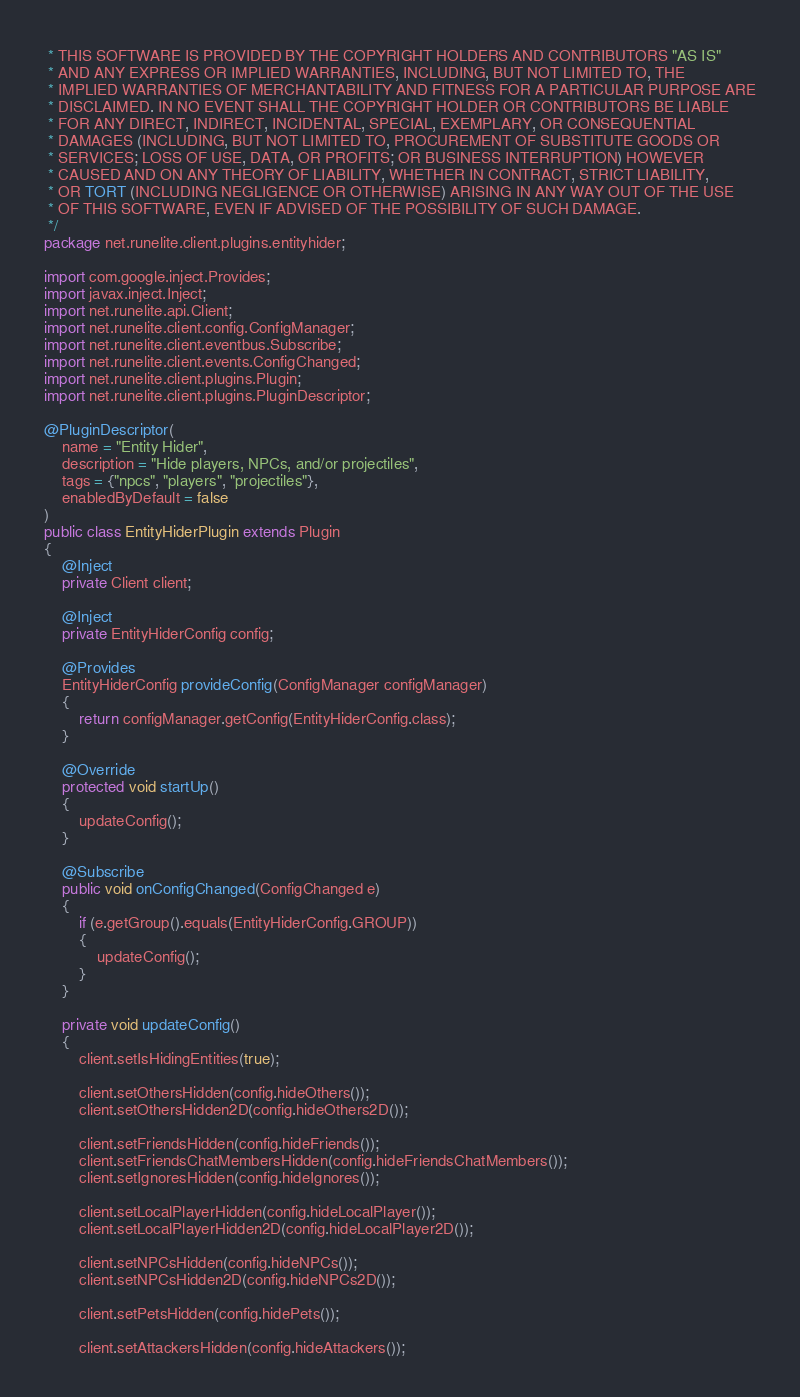<code> <loc_0><loc_0><loc_500><loc_500><_Java_> * THIS SOFTWARE IS PROVIDED BY THE COPYRIGHT HOLDERS AND CONTRIBUTORS "AS IS"
 * AND ANY EXPRESS OR IMPLIED WARRANTIES, INCLUDING, BUT NOT LIMITED TO, THE
 * IMPLIED WARRANTIES OF MERCHANTABILITY AND FITNESS FOR A PARTICULAR PURPOSE ARE
 * DISCLAIMED. IN NO EVENT SHALL THE COPYRIGHT HOLDER OR CONTRIBUTORS BE LIABLE
 * FOR ANY DIRECT, INDIRECT, INCIDENTAL, SPECIAL, EXEMPLARY, OR CONSEQUENTIAL
 * DAMAGES (INCLUDING, BUT NOT LIMITED TO, PROCUREMENT OF SUBSTITUTE GOODS OR
 * SERVICES; LOSS OF USE, DATA, OR PROFITS; OR BUSINESS INTERRUPTION) HOWEVER
 * CAUSED AND ON ANY THEORY OF LIABILITY, WHETHER IN CONTRACT, STRICT LIABILITY,
 * OR TORT (INCLUDING NEGLIGENCE OR OTHERWISE) ARISING IN ANY WAY OUT OF THE USE
 * OF THIS SOFTWARE, EVEN IF ADVISED OF THE POSSIBILITY OF SUCH DAMAGE.
 */
package net.runelite.client.plugins.entityhider;

import com.google.inject.Provides;
import javax.inject.Inject;
import net.runelite.api.Client;
import net.runelite.client.config.ConfigManager;
import net.runelite.client.eventbus.Subscribe;
import net.runelite.client.events.ConfigChanged;
import net.runelite.client.plugins.Plugin;
import net.runelite.client.plugins.PluginDescriptor;

@PluginDescriptor(
	name = "Entity Hider",
	description = "Hide players, NPCs, and/or projectiles",
	tags = {"npcs", "players", "projectiles"},
	enabledByDefault = false
)
public class EntityHiderPlugin extends Plugin
{
	@Inject
	private Client client;

	@Inject
	private EntityHiderConfig config;

	@Provides
	EntityHiderConfig provideConfig(ConfigManager configManager)
	{
		return configManager.getConfig(EntityHiderConfig.class);
	}

	@Override
	protected void startUp()
	{
		updateConfig();
	}

	@Subscribe
	public void onConfigChanged(ConfigChanged e)
	{
		if (e.getGroup().equals(EntityHiderConfig.GROUP))
		{
			updateConfig();
		}
	}

	private void updateConfig()
	{
		client.setIsHidingEntities(true);

		client.setOthersHidden(config.hideOthers());
		client.setOthersHidden2D(config.hideOthers2D());

		client.setFriendsHidden(config.hideFriends());
		client.setFriendsChatMembersHidden(config.hideFriendsChatMembers());
		client.setIgnoresHidden(config.hideIgnores());

		client.setLocalPlayerHidden(config.hideLocalPlayer());
		client.setLocalPlayerHidden2D(config.hideLocalPlayer2D());

		client.setNPCsHidden(config.hideNPCs());
		client.setNPCsHidden2D(config.hideNPCs2D());

		client.setPetsHidden(config.hidePets());

		client.setAttackersHidden(config.hideAttackers());
</code> 